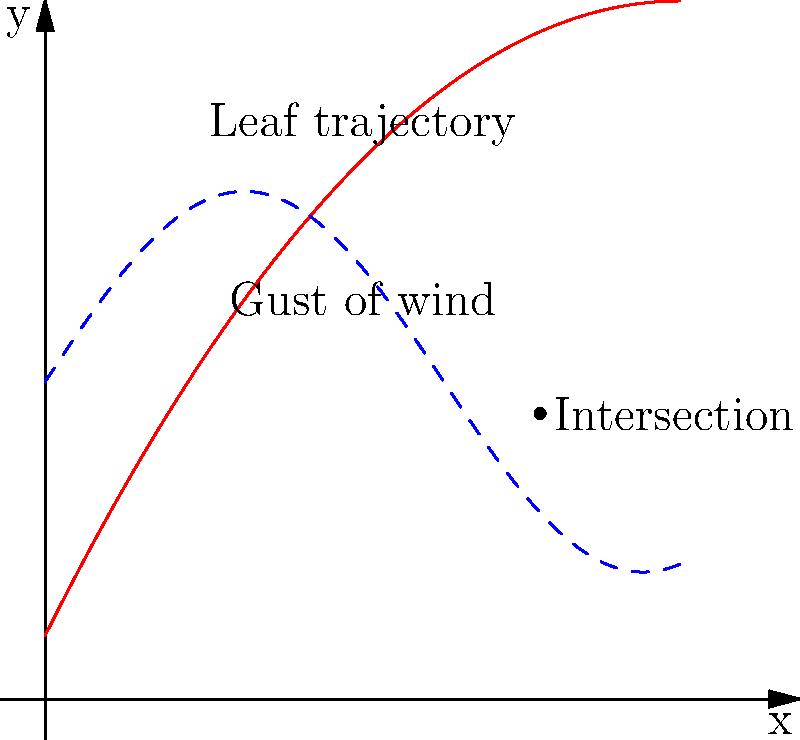In your latest autumn-inspired poem, you describe a falling leaf's dance through the air. To visualize this poetic motion, you decide to plot its trajectory in a Cartesian plane. The leaf's path is represented by the function $f(x) = -0.1x^2 + 2x + 1$ (red curve), while a sudden gust of wind is modeled by $g(x) = 3\sin(x/2) + 5$ (blue dashed curve). At what x-coordinate does the leaf's path intersect with the gust of wind, rounding to the nearest tenth? To find the intersection point, we need to solve the equation:

$$f(x) = g(x)$$

Substituting the given functions:

$$-0.1x^2 + 2x + 1 = 3\sin(x/2) + 5$$

This equation is not easily solvable algebraically, so we'll use a graphical approach:

1. Observe the graph to estimate the intersection point.
2. The red curve (leaf trajectory) and blue dashed curve (wind gust) intersect at approximately x = 7.8.
3. To verify, we can calculate f(7.8) and g(7.8):

   $f(7.8) = -0.1(7.8)^2 + 2(7.8) + 1 \approx 4.52$
   $g(7.8) = 3\sin(7.8/2) + 5 \approx 4.52$

4. The y-values are approximately equal, confirming the intersection.
5. Rounding 7.8 to the nearest tenth gives us 7.8.

Thus, the leaf's path intersects with the gust of wind at x ≈ 7.8.
Answer: 7.8 